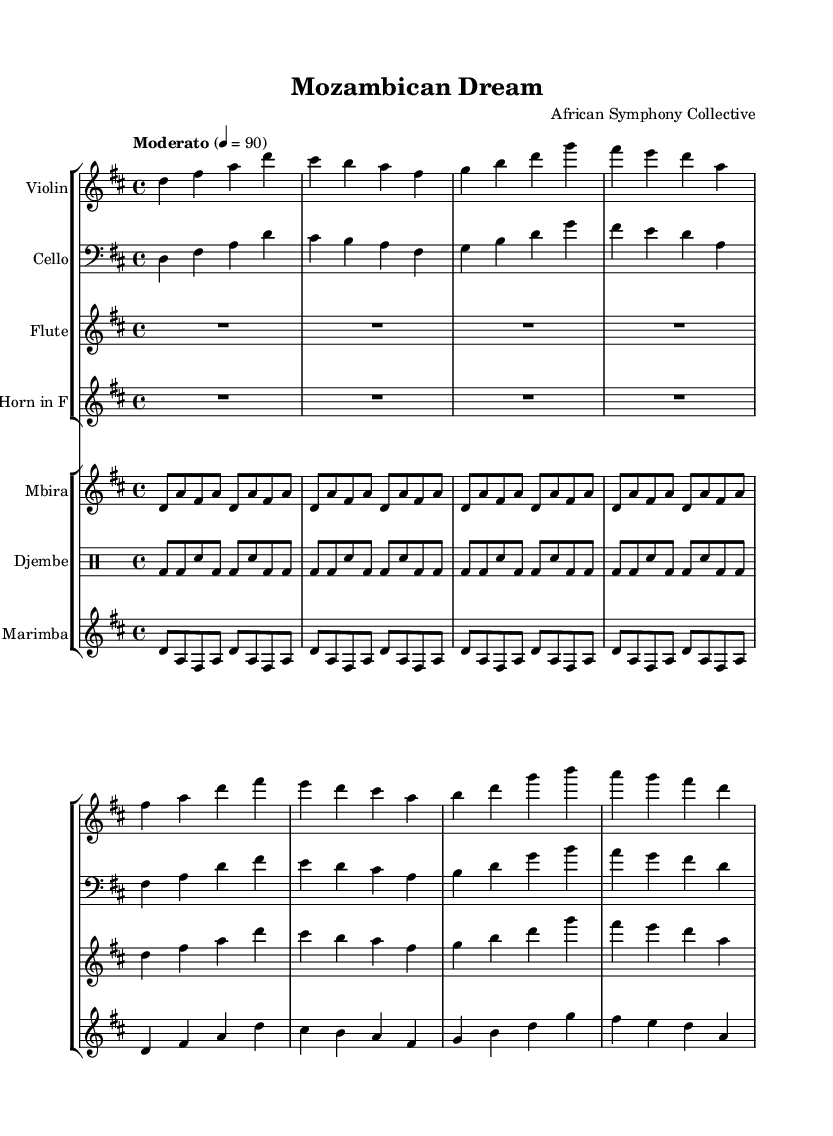What is the key signature of this music? The key signature is indicated by the sharp symbols shown at the beginning of the music. The presence of two sharps signifies the key of D major.
Answer: D major What is the time signature of this music? The time signature is presented as a fraction at the beginning of the sheet music. Here, it shows 4 over 4, which indicates a common time signature.
Answer: 4/4 What is the tempo marking for the piece? The tempo marking is shown as "Moderato" and the number 4 = 90 indicates the beats per minute. This means a moderate speed is suggested for the performance.
Answer: Moderato, 90 Which instruments are included in the first staff group? The instruments in the first staff group are listed next to their respective staves. The instruments included here are Violin, Cello, Flute, and Horn in F.
Answer: Violin, Cello, Flute, Horn in F How many times is the mbira motif repeated in its section? The mbira section has a repeat indication that suggests it is played four times as indicated by the repeat directive. Each cycle contains a specific melodic figure that is played repeatedly.
Answer: 4 Which instrument plays the drum pattern? The drum pattern is specified in the drum staff labeled "Djembe." In this staff, the rhythmic shape is displayed indicating the role of this instrument in the ensemble.
Answer: Djembe How does the marimba part relate to the overall form of the symphony? The marimba music is structured similarly to the other melodic instruments, featuring a repeating motif and contributing to the overall fusion of cultures in the symphony. It complements the melody and harmonizes with traditional African stylistic elements.
Answer: It complements and harmonizes 